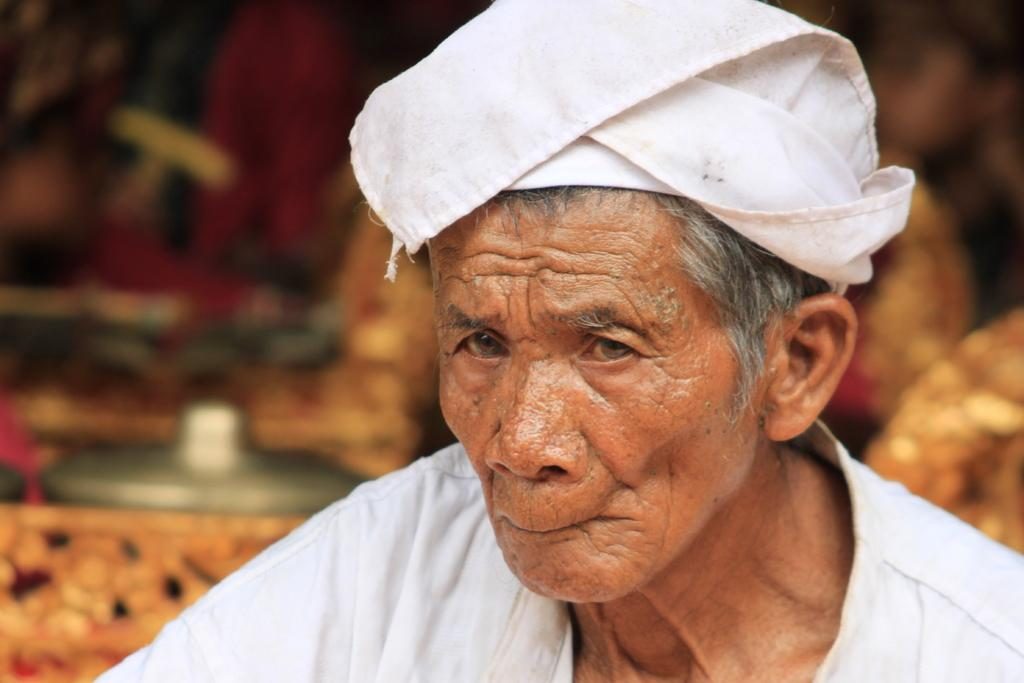Who is present in the image? There is a man in the image. What is on the man's head? The man has a cloth on his head. Can you describe the background of the image? The background of the image is blurry. What type of bushes can be seen in the image? There are no bushes present in the image. What is inside the drawer in the image? There is no drawer present in the image. 